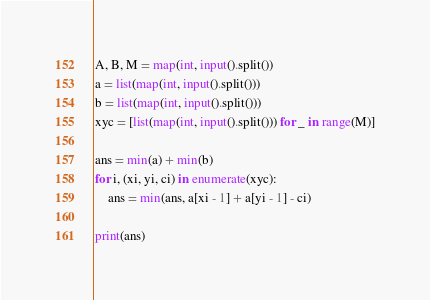<code> <loc_0><loc_0><loc_500><loc_500><_Python_>A, B, M = map(int, input().split())
a = list(map(int, input().split()))
b = list(map(int, input().split()))
xyc = [list(map(int, input().split())) for _ in range(M)]

ans = min(a) + min(b)
for i, (xi, yi, ci) in enumerate(xyc):
    ans = min(ans, a[xi - 1] + a[yi - 1] - ci)

print(ans)</code> 